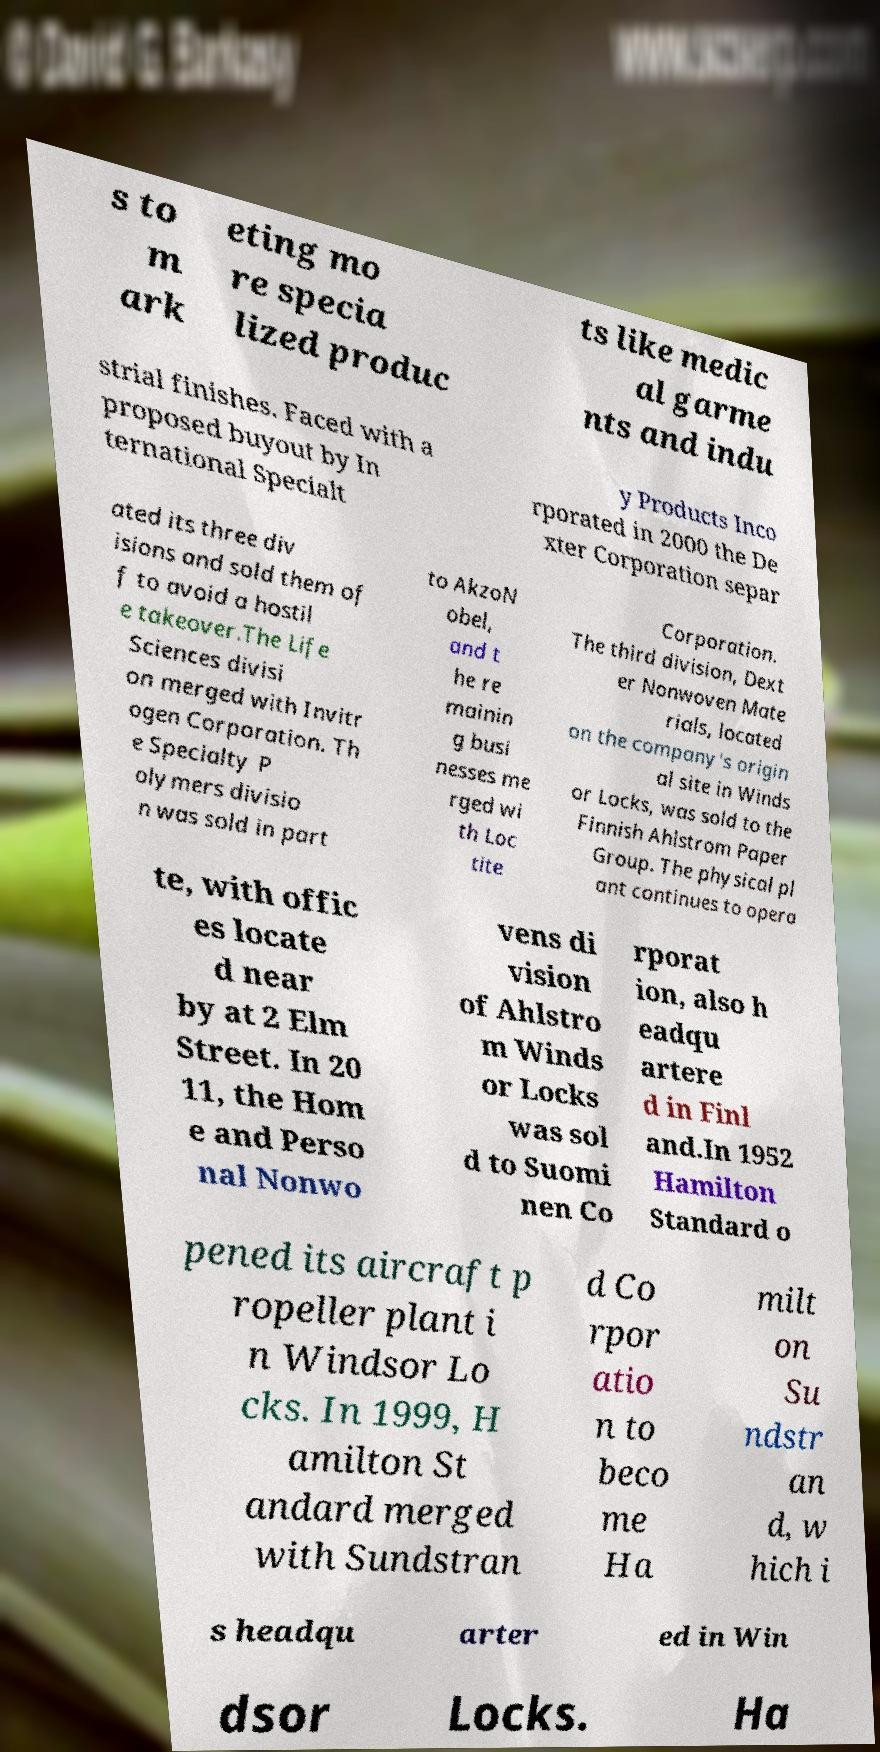Can you accurately transcribe the text from the provided image for me? s to m ark eting mo re specia lized produc ts like medic al garme nts and indu strial finishes. Faced with a proposed buyout by In ternational Specialt y Products Inco rporated in 2000 the De xter Corporation separ ated its three div isions and sold them of f to avoid a hostil e takeover.The Life Sciences divisi on merged with Invitr ogen Corporation. Th e Specialty P olymers divisio n was sold in part to AkzoN obel, and t he re mainin g busi nesses me rged wi th Loc tite Corporation. The third division, Dext er Nonwoven Mate rials, located on the company's origin al site in Winds or Locks, was sold to the Finnish Ahlstrom Paper Group. The physical pl ant continues to opera te, with offic es locate d near by at 2 Elm Street. In 20 11, the Hom e and Perso nal Nonwo vens di vision of Ahlstro m Winds or Locks was sol d to Suomi nen Co rporat ion, also h eadqu artere d in Finl and.In 1952 Hamilton Standard o pened its aircraft p ropeller plant i n Windsor Lo cks. In 1999, H amilton St andard merged with Sundstran d Co rpor atio n to beco me Ha milt on Su ndstr an d, w hich i s headqu arter ed in Win dsor Locks. Ha 